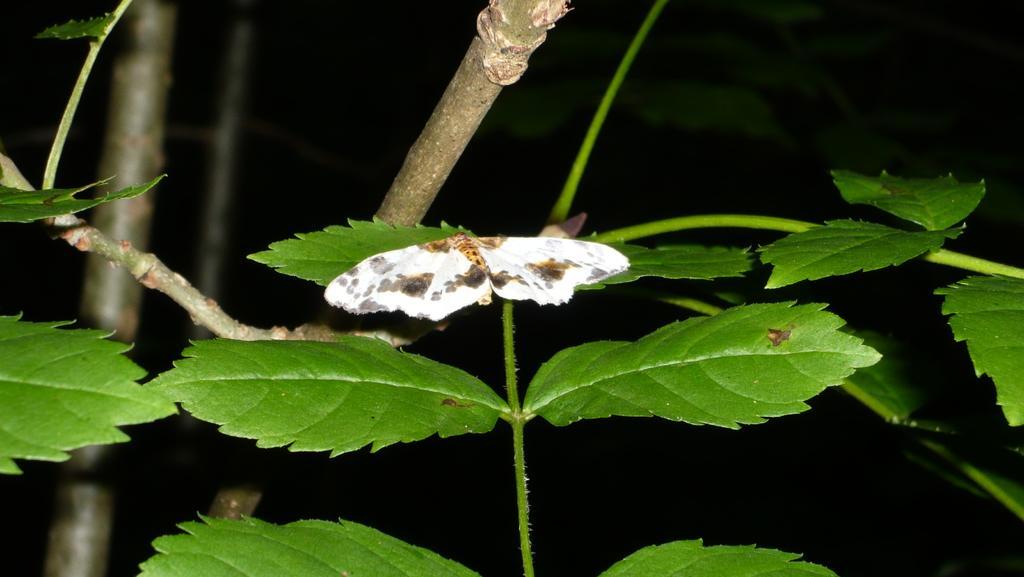Please provide a concise description of this image. In this image, we can see some leaves on the black background. There is a butterfly in the middle of the image. 